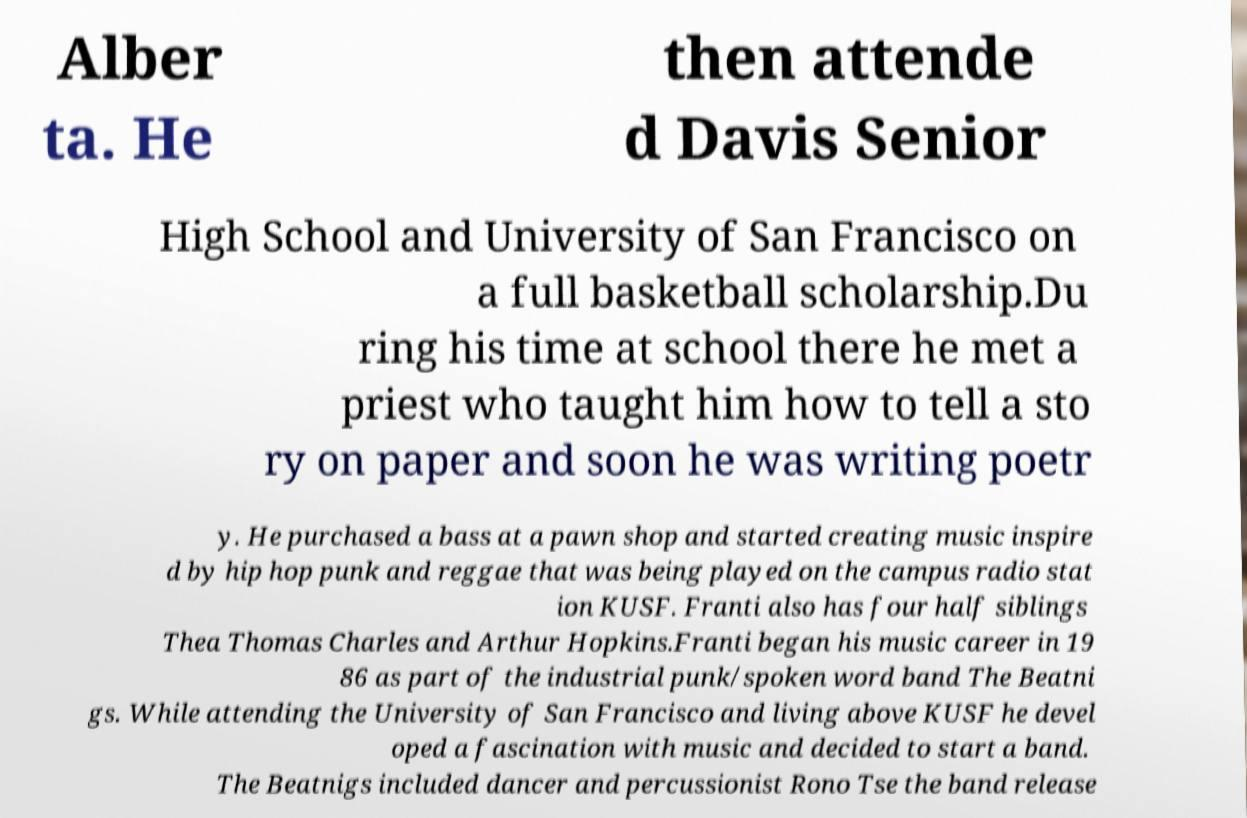There's text embedded in this image that I need extracted. Can you transcribe it verbatim? Alber ta. He then attende d Davis Senior High School and University of San Francisco on a full basketball scholarship.Du ring his time at school there he met a priest who taught him how to tell a sto ry on paper and soon he was writing poetr y. He purchased a bass at a pawn shop and started creating music inspire d by hip hop punk and reggae that was being played on the campus radio stat ion KUSF. Franti also has four half siblings Thea Thomas Charles and Arthur Hopkins.Franti began his music career in 19 86 as part of the industrial punk/spoken word band The Beatni gs. While attending the University of San Francisco and living above KUSF he devel oped a fascination with music and decided to start a band. The Beatnigs included dancer and percussionist Rono Tse the band release 